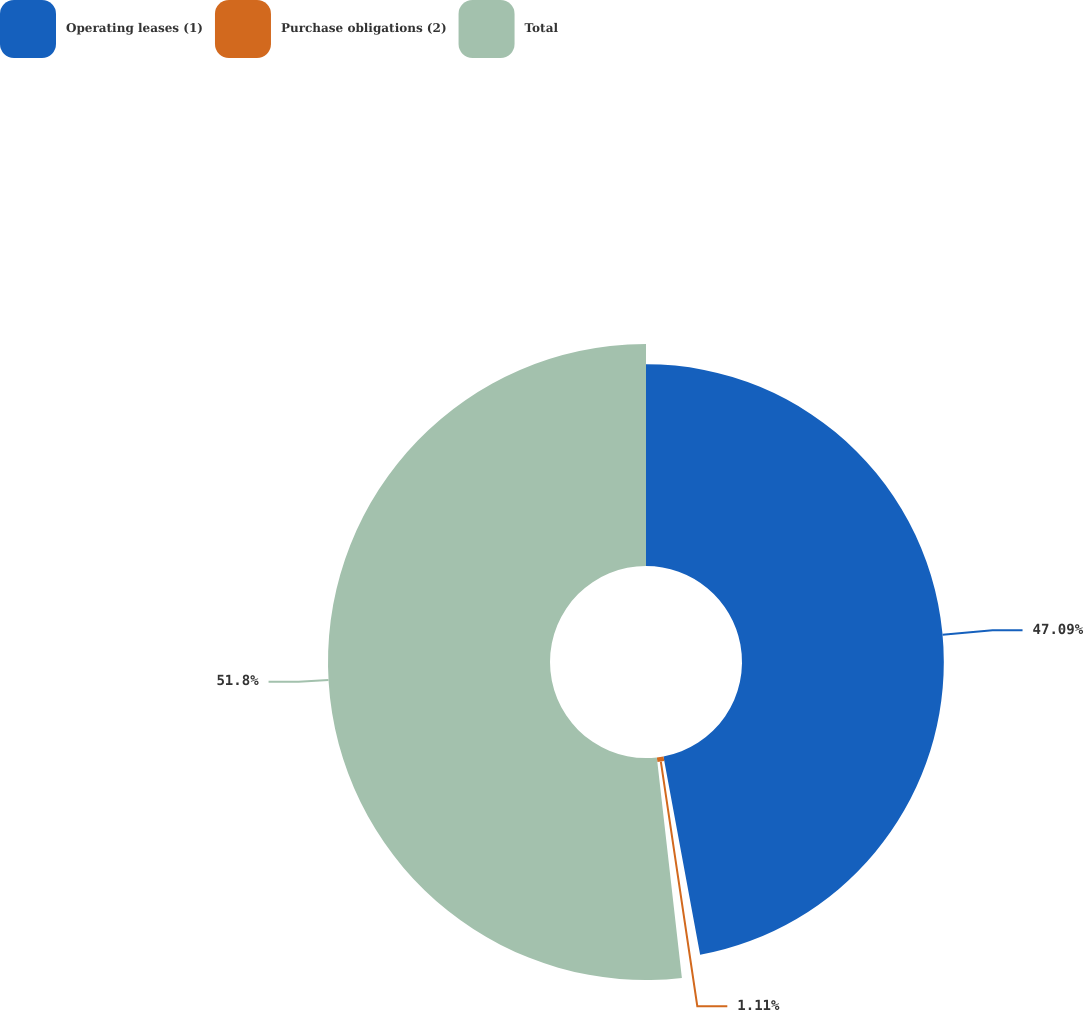Convert chart to OTSL. <chart><loc_0><loc_0><loc_500><loc_500><pie_chart><fcel>Operating leases (1)<fcel>Purchase obligations (2)<fcel>Total<nl><fcel>47.09%<fcel>1.11%<fcel>51.8%<nl></chart> 